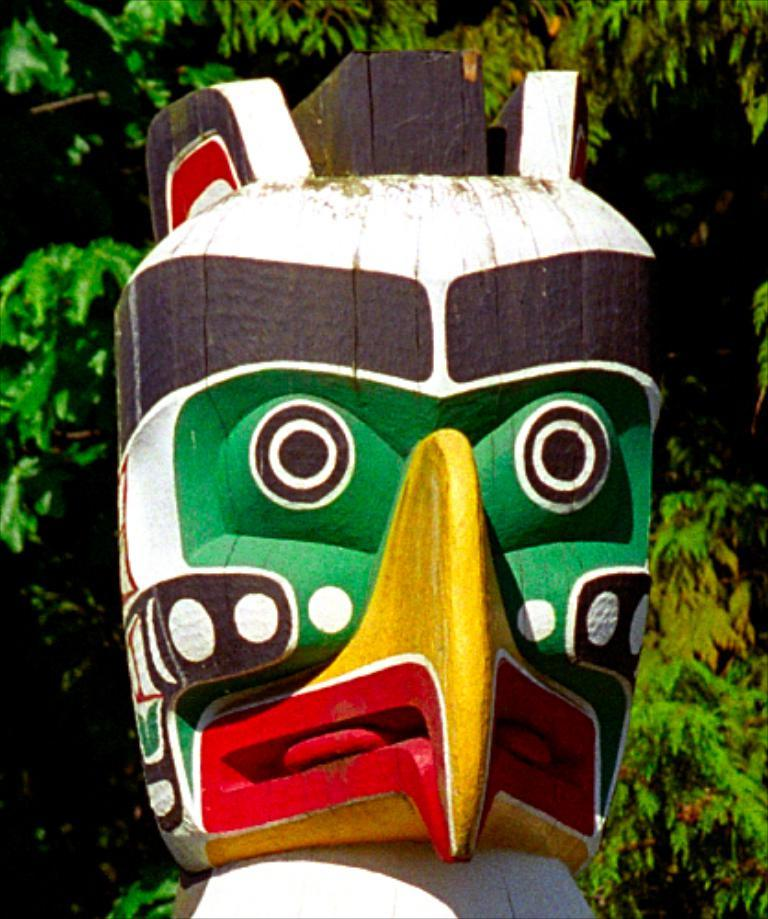What is the main subject in the foreground of the image? There is a man-made wooden-like structure in the foreground of the image. Where is the structure located in the image? The structure is placed in the middle of the image. What can be seen in the background of the image? There is a tree visible in the background of the image. What type of pump is connected to the wooden-like structure in the image? There is no pump connected to the wooden-like structure in the image. How is the thread used in the image? There is no thread present in the image. 